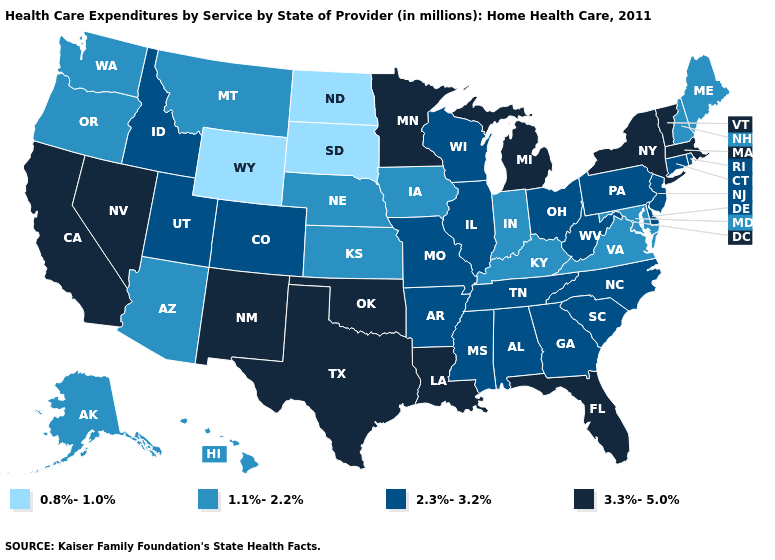What is the lowest value in the USA?
Answer briefly. 0.8%-1.0%. Does Nebraska have the lowest value in the MidWest?
Short answer required. No. Name the states that have a value in the range 0.8%-1.0%?
Write a very short answer. North Dakota, South Dakota, Wyoming. Does Vermont have a lower value than Florida?
Concise answer only. No. Does Wisconsin have a higher value than Arkansas?
Write a very short answer. No. What is the highest value in the USA?
Give a very brief answer. 3.3%-5.0%. What is the highest value in states that border Idaho?
Be succinct. 3.3%-5.0%. Does New York have the highest value in the USA?
Short answer required. Yes. How many symbols are there in the legend?
Keep it brief. 4. Does the map have missing data?
Keep it brief. No. Which states have the highest value in the USA?
Give a very brief answer. California, Florida, Louisiana, Massachusetts, Michigan, Minnesota, Nevada, New Mexico, New York, Oklahoma, Texas, Vermont. Among the states that border New Hampshire , which have the highest value?
Be succinct. Massachusetts, Vermont. Name the states that have a value in the range 0.8%-1.0%?
Be succinct. North Dakota, South Dakota, Wyoming. How many symbols are there in the legend?
Give a very brief answer. 4. Name the states that have a value in the range 2.3%-3.2%?
Short answer required. Alabama, Arkansas, Colorado, Connecticut, Delaware, Georgia, Idaho, Illinois, Mississippi, Missouri, New Jersey, North Carolina, Ohio, Pennsylvania, Rhode Island, South Carolina, Tennessee, Utah, West Virginia, Wisconsin. 